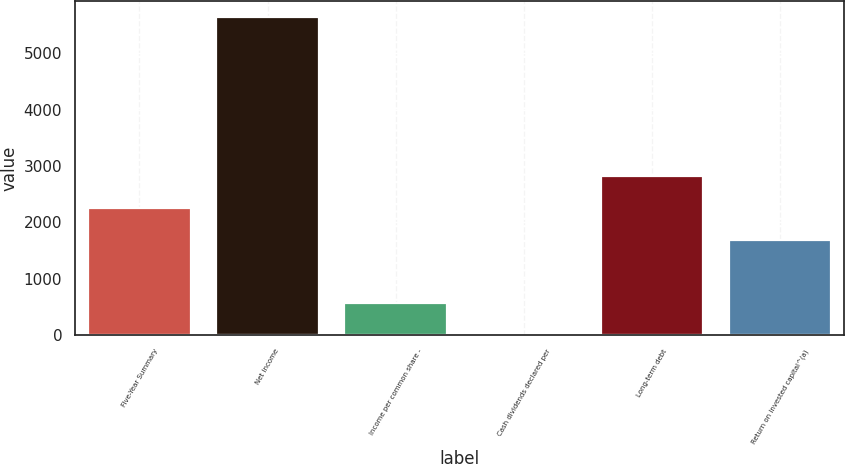Convert chart. <chart><loc_0><loc_0><loc_500><loc_500><bar_chart><fcel>Five-Year Summary<fcel>Net income<fcel>Income per common share -<fcel>Cash dividends declared per<fcel>Long-term debt<fcel>Return on invested capital^(a)<nl><fcel>2257.48<fcel>5642<fcel>565.24<fcel>1.16<fcel>2821.56<fcel>1693.4<nl></chart> 